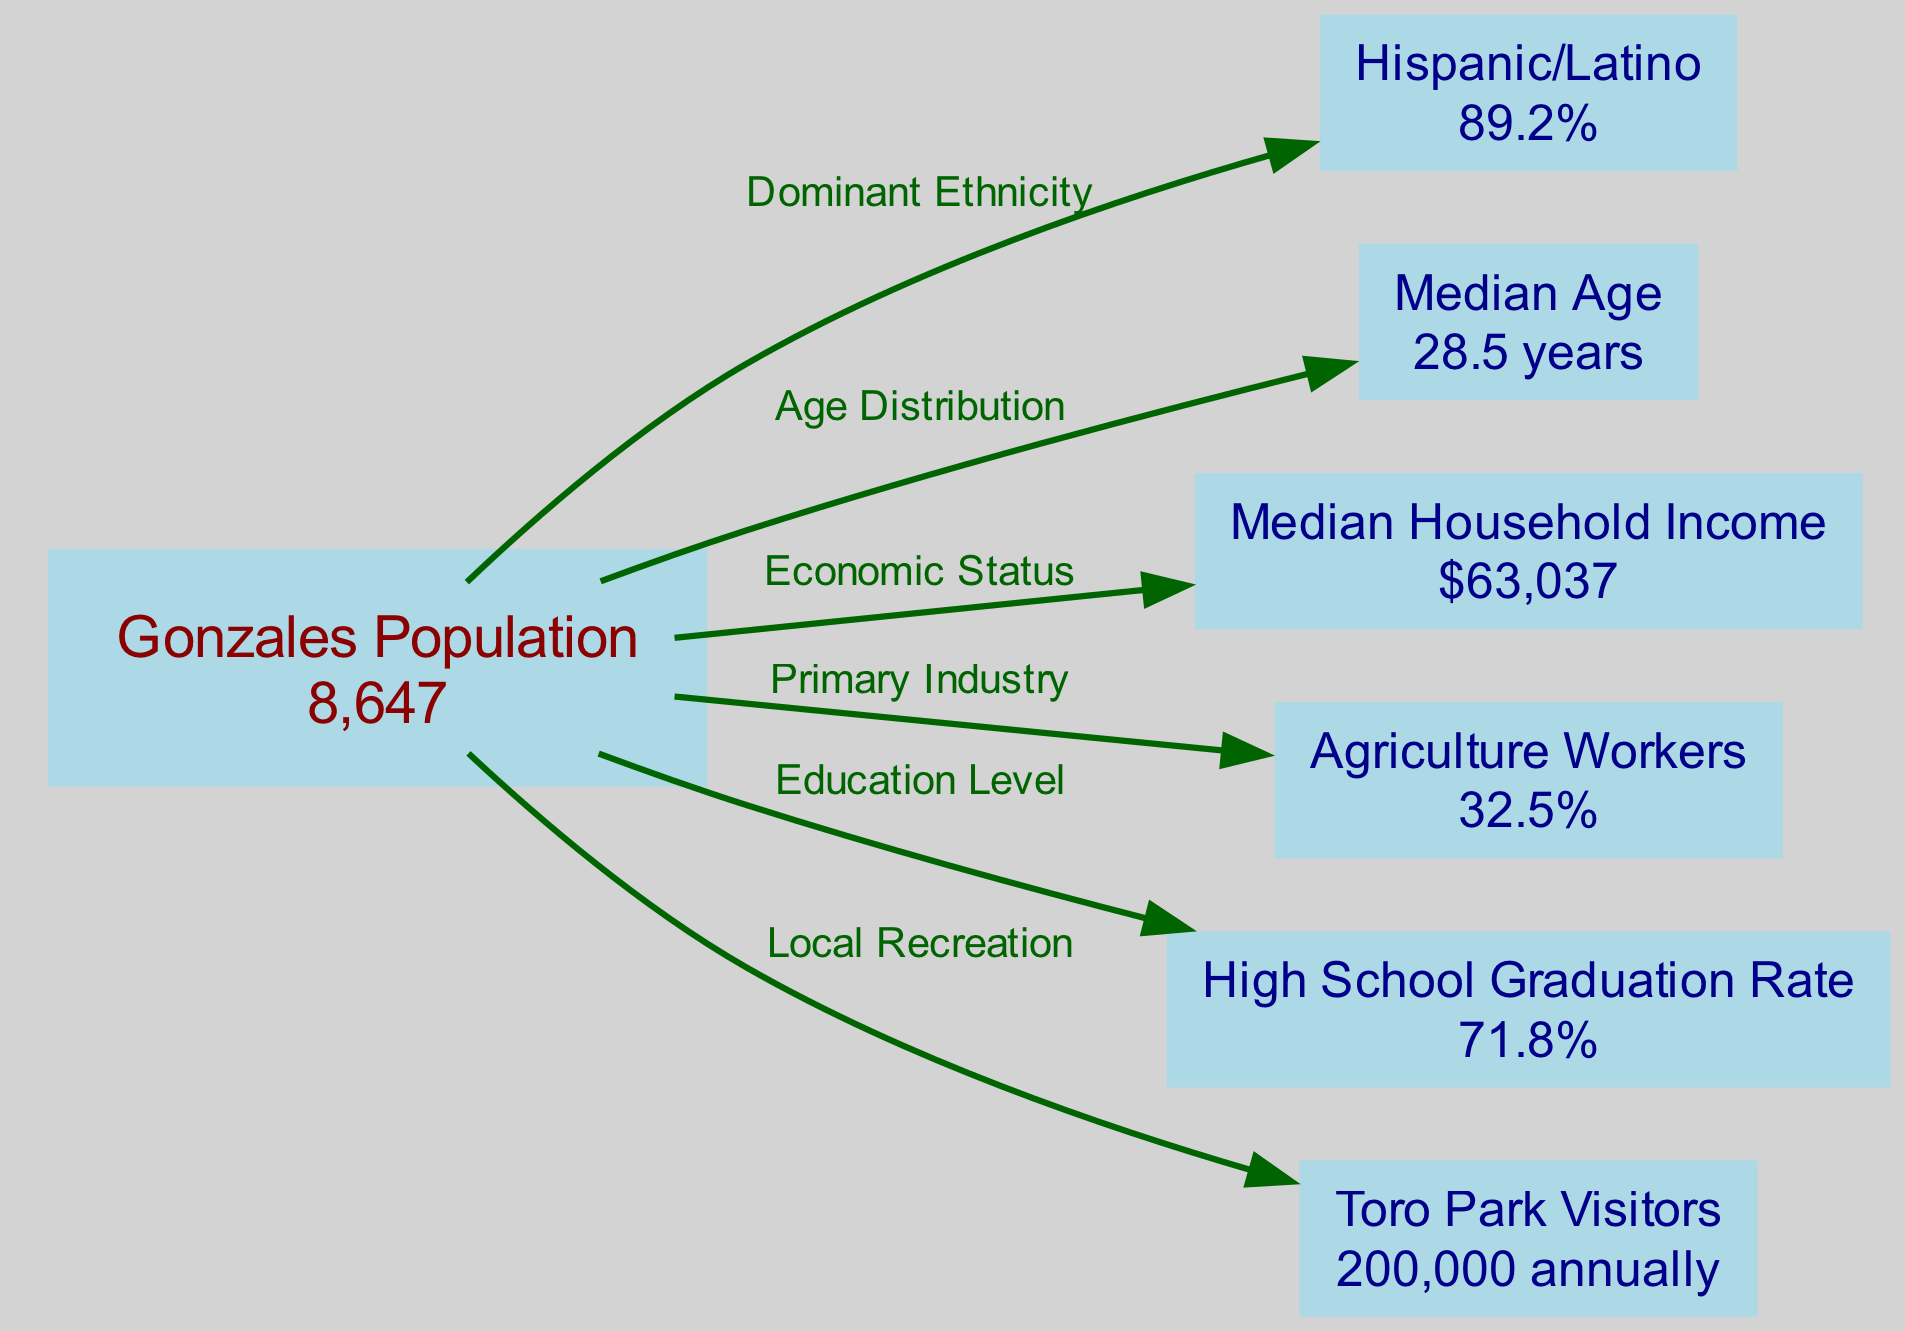What is the total population of Gonzales? The diagram directly states that the population of Gonzales is 8,647.
Answer: 8,647 What percentage of Gonzales's population identifies as Hispanic or Latino? The diagram shows that the Hispanic/Latino population is 89.2%, as labeled under the corresponding node.
Answer: 89.2% What is the median household income in Gonzales? According to the diagram, the value given for median household income is $63,037.
Answer: $63,037 Which node indicates the primary industry in Gonzales? The node for Agriculture Workers indicates the primary industry, which is shown as 32.5% in the diagram.
Answer: Agriculture Workers What is the relationship between Gonzales's population and high school graduation rate? The diagram connects Gonzales's population to the high school graduation rate node, indicating that 71.8% of individuals graduate high school in the community.
Answer: 71.8% How does the median age of Gonzales compare to the high school graduation rate? The median age of Gonzales is 28.5 years, which can be found in the corresponding node. The graduation rate is also relevant and noted as 71.8%, showing differing demographic aspects.
Answer: 28.5 years and 71.8% What can be inferred about local recreation in Gonzales? The node labeled Toro Park Visitors states that there are 200,000 visitors annually, highlighting a vibrant local recreational activity within the community.
Answer: 200,000 annually How many nodes are represented in the diagram? Counting the nodes within the provided data section, there are a total of 7 nodes that are related to Gonzales’s demographics and socioeconomic indicators.
Answer: 7 What relationship does agriculture workers have with the overall population? The edge indicating that agriculture workers represent 32.5% of the overall population shows that a significant portion of Gonzales's economy is reliant on this industry.
Answer: 32.5% What does the edge labeled "Economic Status" connect? The edge "Economic Status" connects the overall population node to the median household income node, providing insight into the community’s financial situation.
Answer: Median Household Income 